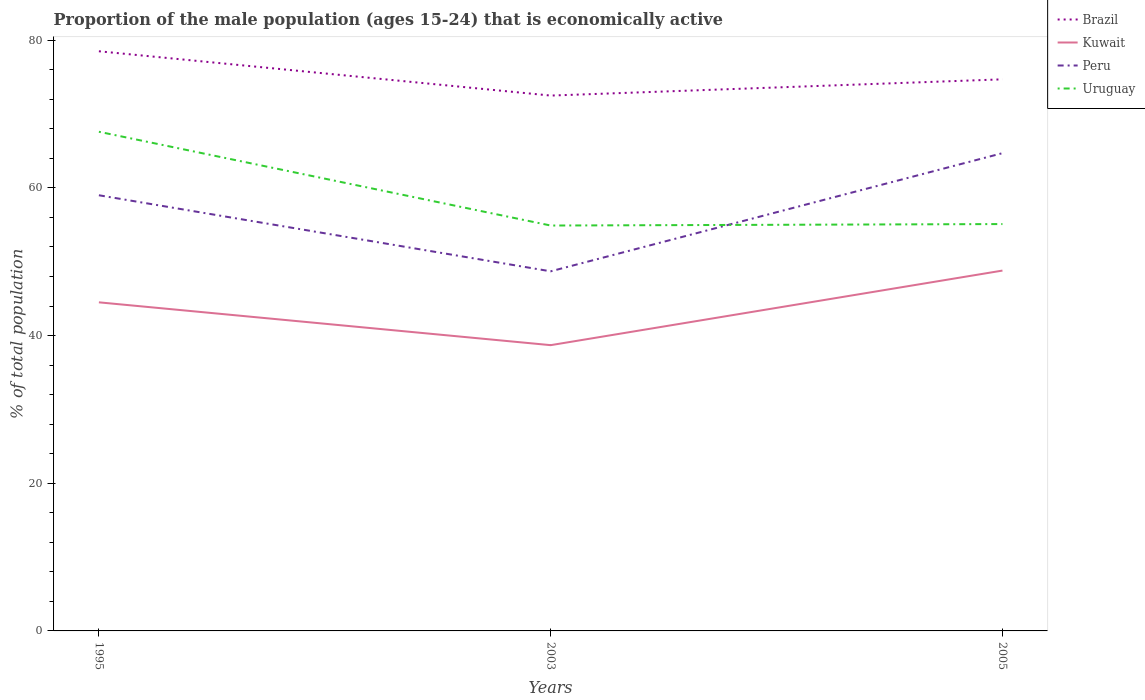How many different coloured lines are there?
Provide a succinct answer. 4. Is the number of lines equal to the number of legend labels?
Offer a very short reply. Yes. Across all years, what is the maximum proportion of the male population that is economically active in Brazil?
Offer a very short reply. 72.5. In which year was the proportion of the male population that is economically active in Uruguay maximum?
Offer a terse response. 2003. What is the total proportion of the male population that is economically active in Brazil in the graph?
Ensure brevity in your answer.  3.8. What is the difference between the highest and the second highest proportion of the male population that is economically active in Peru?
Provide a succinct answer. 16. What is the difference between the highest and the lowest proportion of the male population that is economically active in Brazil?
Give a very brief answer. 1. Is the proportion of the male population that is economically active in Uruguay strictly greater than the proportion of the male population that is economically active in Brazil over the years?
Your answer should be compact. Yes. Are the values on the major ticks of Y-axis written in scientific E-notation?
Offer a very short reply. No. Does the graph contain grids?
Make the answer very short. No. Where does the legend appear in the graph?
Give a very brief answer. Top right. How many legend labels are there?
Your answer should be compact. 4. How are the legend labels stacked?
Offer a terse response. Vertical. What is the title of the graph?
Your answer should be very brief. Proportion of the male population (ages 15-24) that is economically active. What is the label or title of the Y-axis?
Offer a very short reply. % of total population. What is the % of total population in Brazil in 1995?
Your answer should be very brief. 78.5. What is the % of total population of Kuwait in 1995?
Your answer should be very brief. 44.5. What is the % of total population in Uruguay in 1995?
Offer a terse response. 67.6. What is the % of total population of Brazil in 2003?
Your answer should be very brief. 72.5. What is the % of total population of Kuwait in 2003?
Provide a short and direct response. 38.7. What is the % of total population of Peru in 2003?
Your response must be concise. 48.7. What is the % of total population in Uruguay in 2003?
Ensure brevity in your answer.  54.9. What is the % of total population in Brazil in 2005?
Ensure brevity in your answer.  74.7. What is the % of total population of Kuwait in 2005?
Give a very brief answer. 48.8. What is the % of total population in Peru in 2005?
Offer a terse response. 64.7. What is the % of total population in Uruguay in 2005?
Offer a very short reply. 55.1. Across all years, what is the maximum % of total population in Brazil?
Keep it short and to the point. 78.5. Across all years, what is the maximum % of total population of Kuwait?
Your answer should be compact. 48.8. Across all years, what is the maximum % of total population in Peru?
Your answer should be very brief. 64.7. Across all years, what is the maximum % of total population of Uruguay?
Your answer should be compact. 67.6. Across all years, what is the minimum % of total population in Brazil?
Ensure brevity in your answer.  72.5. Across all years, what is the minimum % of total population in Kuwait?
Your answer should be very brief. 38.7. Across all years, what is the minimum % of total population in Peru?
Give a very brief answer. 48.7. Across all years, what is the minimum % of total population in Uruguay?
Your response must be concise. 54.9. What is the total % of total population in Brazil in the graph?
Give a very brief answer. 225.7. What is the total % of total population in Kuwait in the graph?
Offer a very short reply. 132. What is the total % of total population of Peru in the graph?
Keep it short and to the point. 172.4. What is the total % of total population in Uruguay in the graph?
Keep it short and to the point. 177.6. What is the difference between the % of total population in Peru in 1995 and that in 2003?
Provide a succinct answer. 10.3. What is the difference between the % of total population of Brazil in 1995 and that in 2005?
Offer a terse response. 3.8. What is the difference between the % of total population in Kuwait in 1995 and that in 2005?
Keep it short and to the point. -4.3. What is the difference between the % of total population in Peru in 2003 and that in 2005?
Your response must be concise. -16. What is the difference between the % of total population of Uruguay in 2003 and that in 2005?
Make the answer very short. -0.2. What is the difference between the % of total population in Brazil in 1995 and the % of total population in Kuwait in 2003?
Your answer should be compact. 39.8. What is the difference between the % of total population of Brazil in 1995 and the % of total population of Peru in 2003?
Offer a very short reply. 29.8. What is the difference between the % of total population of Brazil in 1995 and the % of total population of Uruguay in 2003?
Provide a short and direct response. 23.6. What is the difference between the % of total population of Kuwait in 1995 and the % of total population of Peru in 2003?
Ensure brevity in your answer.  -4.2. What is the difference between the % of total population in Kuwait in 1995 and the % of total population in Uruguay in 2003?
Keep it short and to the point. -10.4. What is the difference between the % of total population of Brazil in 1995 and the % of total population of Kuwait in 2005?
Make the answer very short. 29.7. What is the difference between the % of total population of Brazil in 1995 and the % of total population of Uruguay in 2005?
Offer a very short reply. 23.4. What is the difference between the % of total population of Kuwait in 1995 and the % of total population of Peru in 2005?
Provide a short and direct response. -20.2. What is the difference between the % of total population in Kuwait in 1995 and the % of total population in Uruguay in 2005?
Make the answer very short. -10.6. What is the difference between the % of total population in Peru in 1995 and the % of total population in Uruguay in 2005?
Your answer should be compact. 3.9. What is the difference between the % of total population of Brazil in 2003 and the % of total population of Kuwait in 2005?
Keep it short and to the point. 23.7. What is the difference between the % of total population of Brazil in 2003 and the % of total population of Peru in 2005?
Provide a succinct answer. 7.8. What is the difference between the % of total population of Kuwait in 2003 and the % of total population of Peru in 2005?
Keep it short and to the point. -26. What is the difference between the % of total population in Kuwait in 2003 and the % of total population in Uruguay in 2005?
Ensure brevity in your answer.  -16.4. What is the average % of total population in Brazil per year?
Provide a short and direct response. 75.23. What is the average % of total population in Peru per year?
Provide a short and direct response. 57.47. What is the average % of total population in Uruguay per year?
Ensure brevity in your answer.  59.2. In the year 1995, what is the difference between the % of total population in Brazil and % of total population in Kuwait?
Offer a terse response. 34. In the year 1995, what is the difference between the % of total population of Kuwait and % of total population of Peru?
Ensure brevity in your answer.  -14.5. In the year 1995, what is the difference between the % of total population of Kuwait and % of total population of Uruguay?
Provide a succinct answer. -23.1. In the year 2003, what is the difference between the % of total population in Brazil and % of total population in Kuwait?
Make the answer very short. 33.8. In the year 2003, what is the difference between the % of total population of Brazil and % of total population of Peru?
Give a very brief answer. 23.8. In the year 2003, what is the difference between the % of total population in Brazil and % of total population in Uruguay?
Make the answer very short. 17.6. In the year 2003, what is the difference between the % of total population of Kuwait and % of total population of Uruguay?
Your answer should be very brief. -16.2. In the year 2003, what is the difference between the % of total population of Peru and % of total population of Uruguay?
Keep it short and to the point. -6.2. In the year 2005, what is the difference between the % of total population of Brazil and % of total population of Kuwait?
Give a very brief answer. 25.9. In the year 2005, what is the difference between the % of total population in Brazil and % of total population in Uruguay?
Offer a terse response. 19.6. In the year 2005, what is the difference between the % of total population in Kuwait and % of total population in Peru?
Offer a very short reply. -15.9. In the year 2005, what is the difference between the % of total population of Kuwait and % of total population of Uruguay?
Your answer should be compact. -6.3. What is the ratio of the % of total population of Brazil in 1995 to that in 2003?
Provide a succinct answer. 1.08. What is the ratio of the % of total population of Kuwait in 1995 to that in 2003?
Provide a succinct answer. 1.15. What is the ratio of the % of total population of Peru in 1995 to that in 2003?
Your response must be concise. 1.21. What is the ratio of the % of total population of Uruguay in 1995 to that in 2003?
Keep it short and to the point. 1.23. What is the ratio of the % of total population of Brazil in 1995 to that in 2005?
Offer a terse response. 1.05. What is the ratio of the % of total population of Kuwait in 1995 to that in 2005?
Make the answer very short. 0.91. What is the ratio of the % of total population in Peru in 1995 to that in 2005?
Provide a short and direct response. 0.91. What is the ratio of the % of total population in Uruguay in 1995 to that in 2005?
Provide a succinct answer. 1.23. What is the ratio of the % of total population of Brazil in 2003 to that in 2005?
Your response must be concise. 0.97. What is the ratio of the % of total population of Kuwait in 2003 to that in 2005?
Your response must be concise. 0.79. What is the ratio of the % of total population of Peru in 2003 to that in 2005?
Your answer should be very brief. 0.75. What is the difference between the highest and the lowest % of total population of Peru?
Offer a very short reply. 16. What is the difference between the highest and the lowest % of total population in Uruguay?
Ensure brevity in your answer.  12.7. 